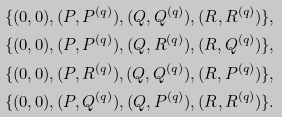<formula> <loc_0><loc_0><loc_500><loc_500>\{ ( 0 , 0 ) , ( P , P ^ { ( q ) } ) , ( Q , Q ^ { ( q ) } ) , ( R , R ^ { ( q ) } ) \} , \\ \{ ( 0 , 0 ) , ( P , P ^ { ( q ) } ) , ( Q , R ^ { ( q ) } ) , ( R , Q ^ { ( q ) } ) \} , \\ \{ ( 0 , 0 ) , ( P , R ^ { ( q ) } ) , ( Q , Q ^ { ( q ) } ) , ( R , P ^ { ( q ) } ) \} , \\ \{ ( 0 , 0 ) , ( P , Q ^ { ( q ) } ) , ( Q , P ^ { ( q ) } ) , ( R , R ^ { ( q ) } ) \} .</formula> 